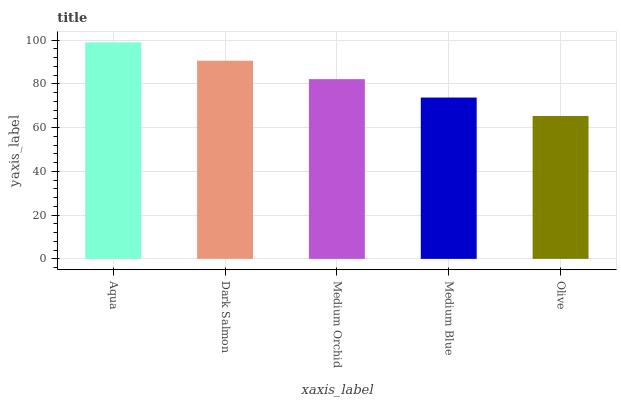Is Dark Salmon the minimum?
Answer yes or no. No. Is Dark Salmon the maximum?
Answer yes or no. No. Is Aqua greater than Dark Salmon?
Answer yes or no. Yes. Is Dark Salmon less than Aqua?
Answer yes or no. Yes. Is Dark Salmon greater than Aqua?
Answer yes or no. No. Is Aqua less than Dark Salmon?
Answer yes or no. No. Is Medium Orchid the high median?
Answer yes or no. Yes. Is Medium Orchid the low median?
Answer yes or no. Yes. Is Aqua the high median?
Answer yes or no. No. Is Medium Blue the low median?
Answer yes or no. No. 